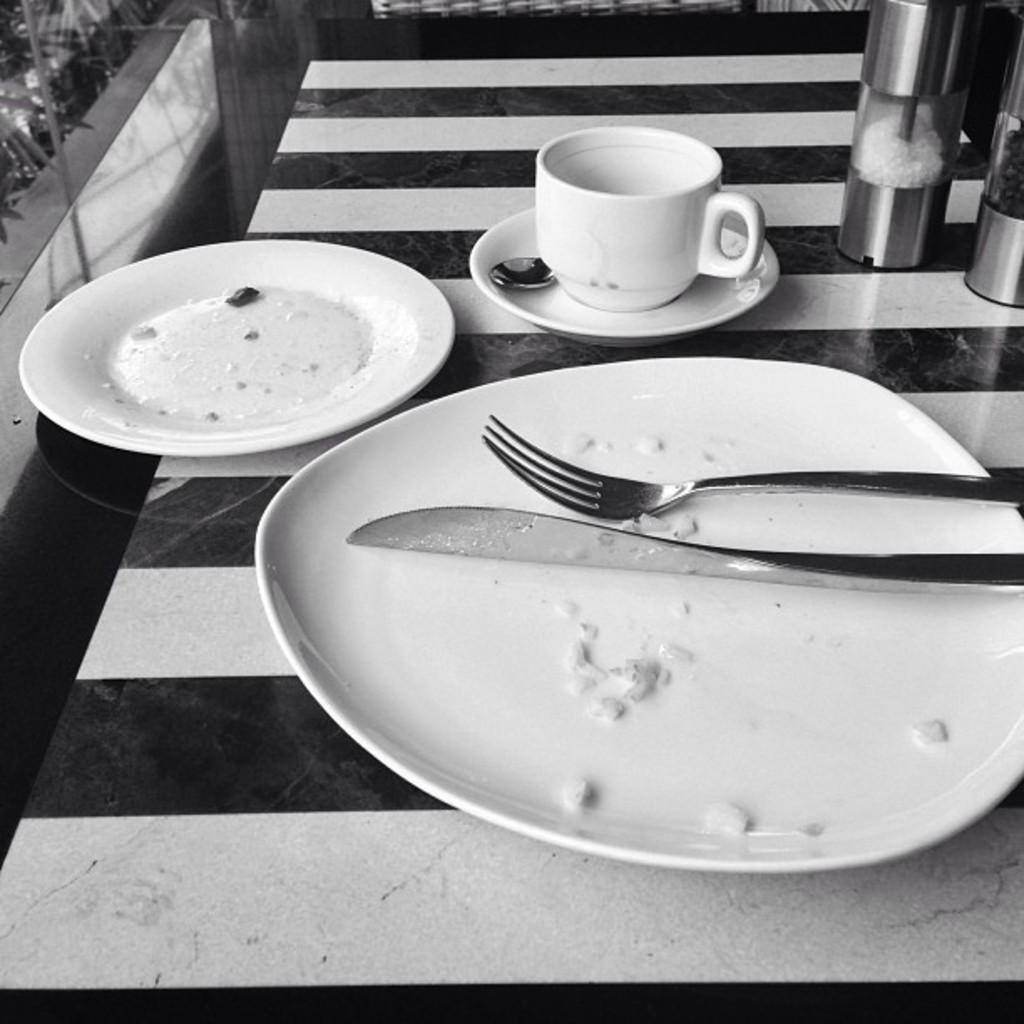In one or two sentences, can you explain what this image depicts? A black and white picture. On this table there are plates, fork, knife, jar and cup. 